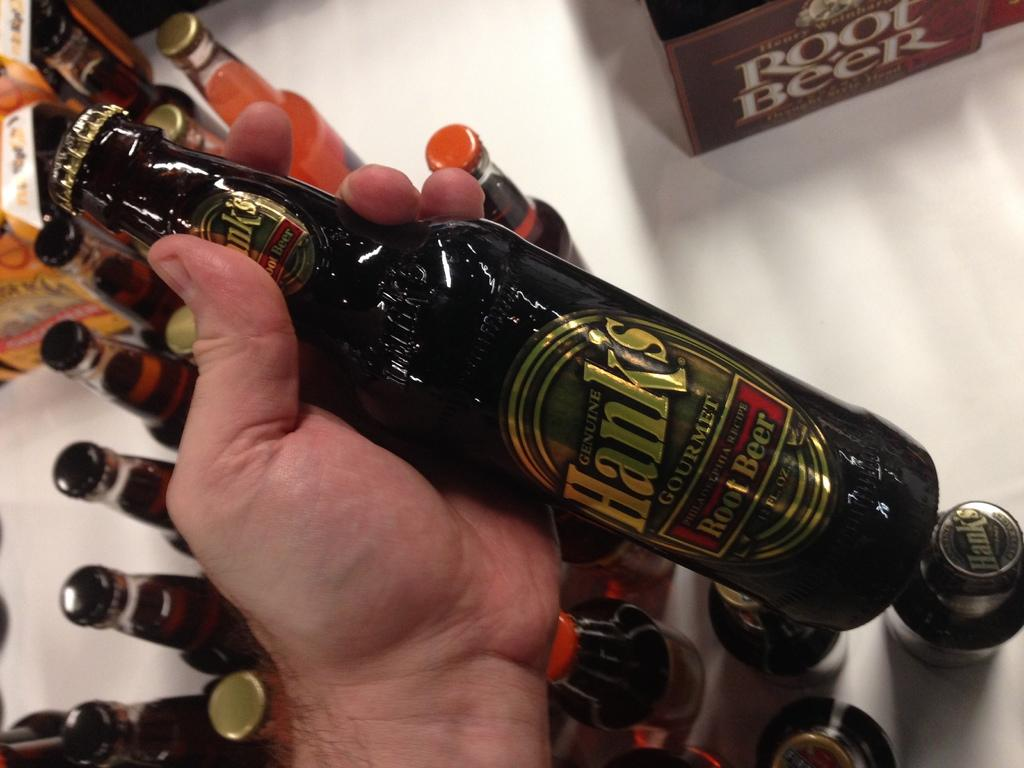What is the person holding in their hand in the image? The person is holding a bottle in their hand. Are there any other bottles visible in the image? Yes, there are multiple bottles on the floor. What other object can be seen in the image? There is a box in the image. What type of acoustics can be heard in the image? There is no information about acoustics in the image, as it only shows a person holding a bottle and multiple bottles on the floor. 